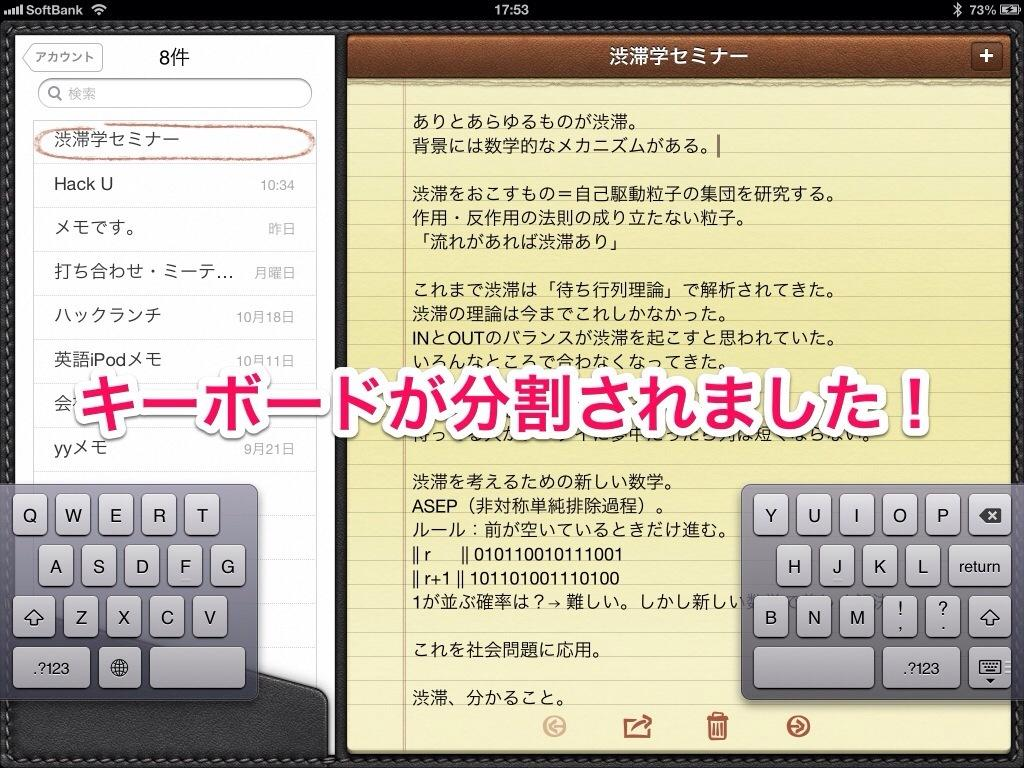<image>
Write a terse but informative summary of the picture. A display screen with Japanese writing on it with the top left corner with the app SoftBank 